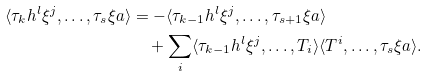<formula> <loc_0><loc_0><loc_500><loc_500>\langle \tau _ { k } h ^ { l } \xi ^ { j } , \dots , \tau _ { s } \xi a \rangle & = - \langle \tau _ { k - 1 } h ^ { l } \xi ^ { j } , \dots , \tau _ { s + 1 } \xi a \rangle \\ & \quad + \sum _ { i } \langle \tau _ { k - 1 } h ^ { l } \xi ^ { j } , \dots , T _ { i } \rangle \langle T ^ { i } , \dots , \tau _ { s } \xi a \rangle .</formula> 